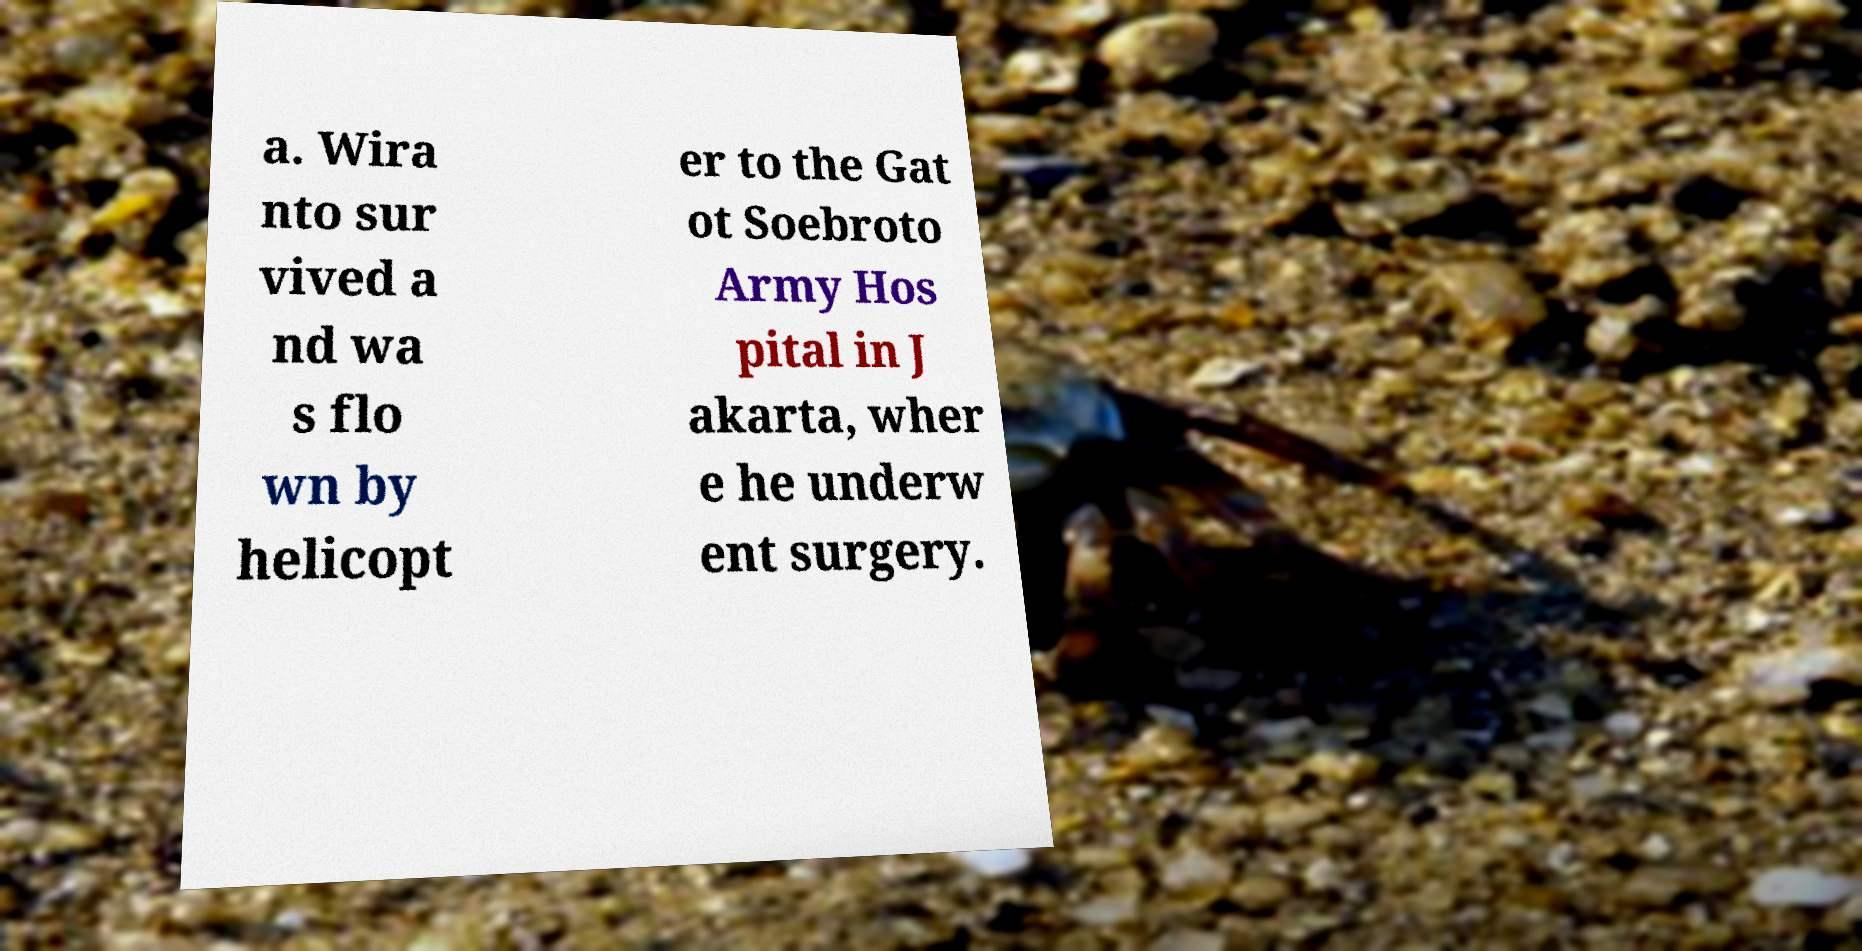Can you accurately transcribe the text from the provided image for me? a. Wira nto sur vived a nd wa s flo wn by helicopt er to the Gat ot Soebroto Army Hos pital in J akarta, wher e he underw ent surgery. 